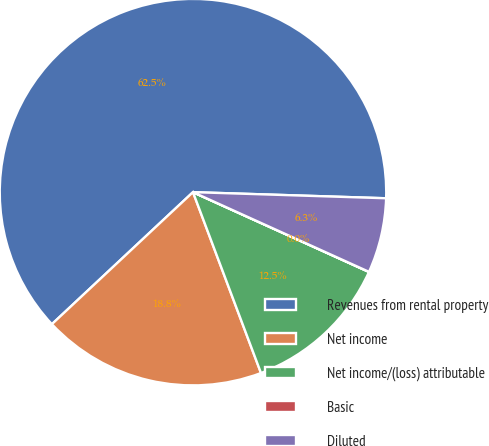Convert chart. <chart><loc_0><loc_0><loc_500><loc_500><pie_chart><fcel>Revenues from rental property<fcel>Net income<fcel>Net income/(loss) attributable<fcel>Basic<fcel>Diluted<nl><fcel>62.47%<fcel>18.75%<fcel>12.5%<fcel>0.01%<fcel>6.26%<nl></chart> 